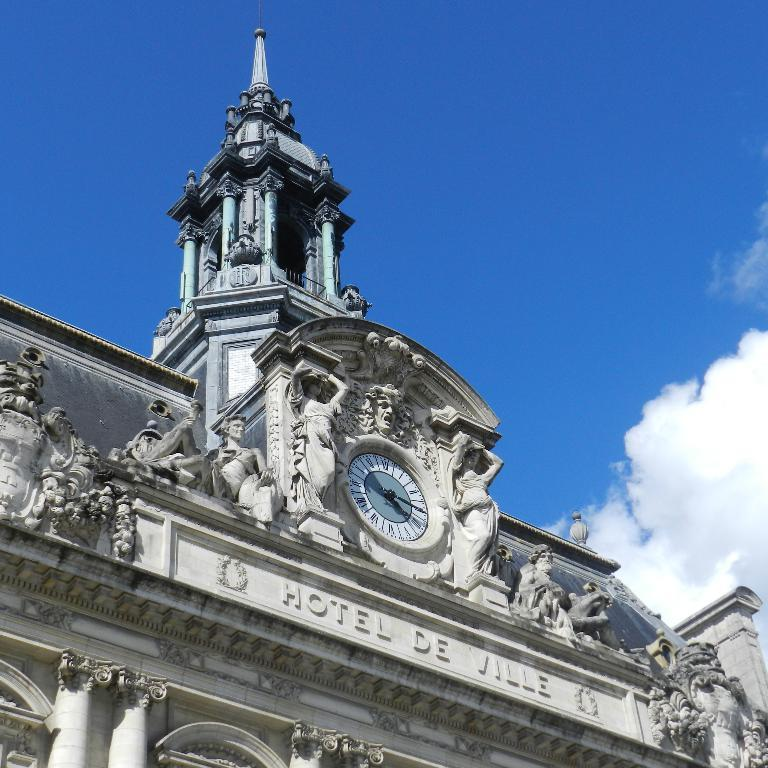<image>
Write a terse but informative summary of the picture. A picture of a grey building that says Hotel De Ville on it. 